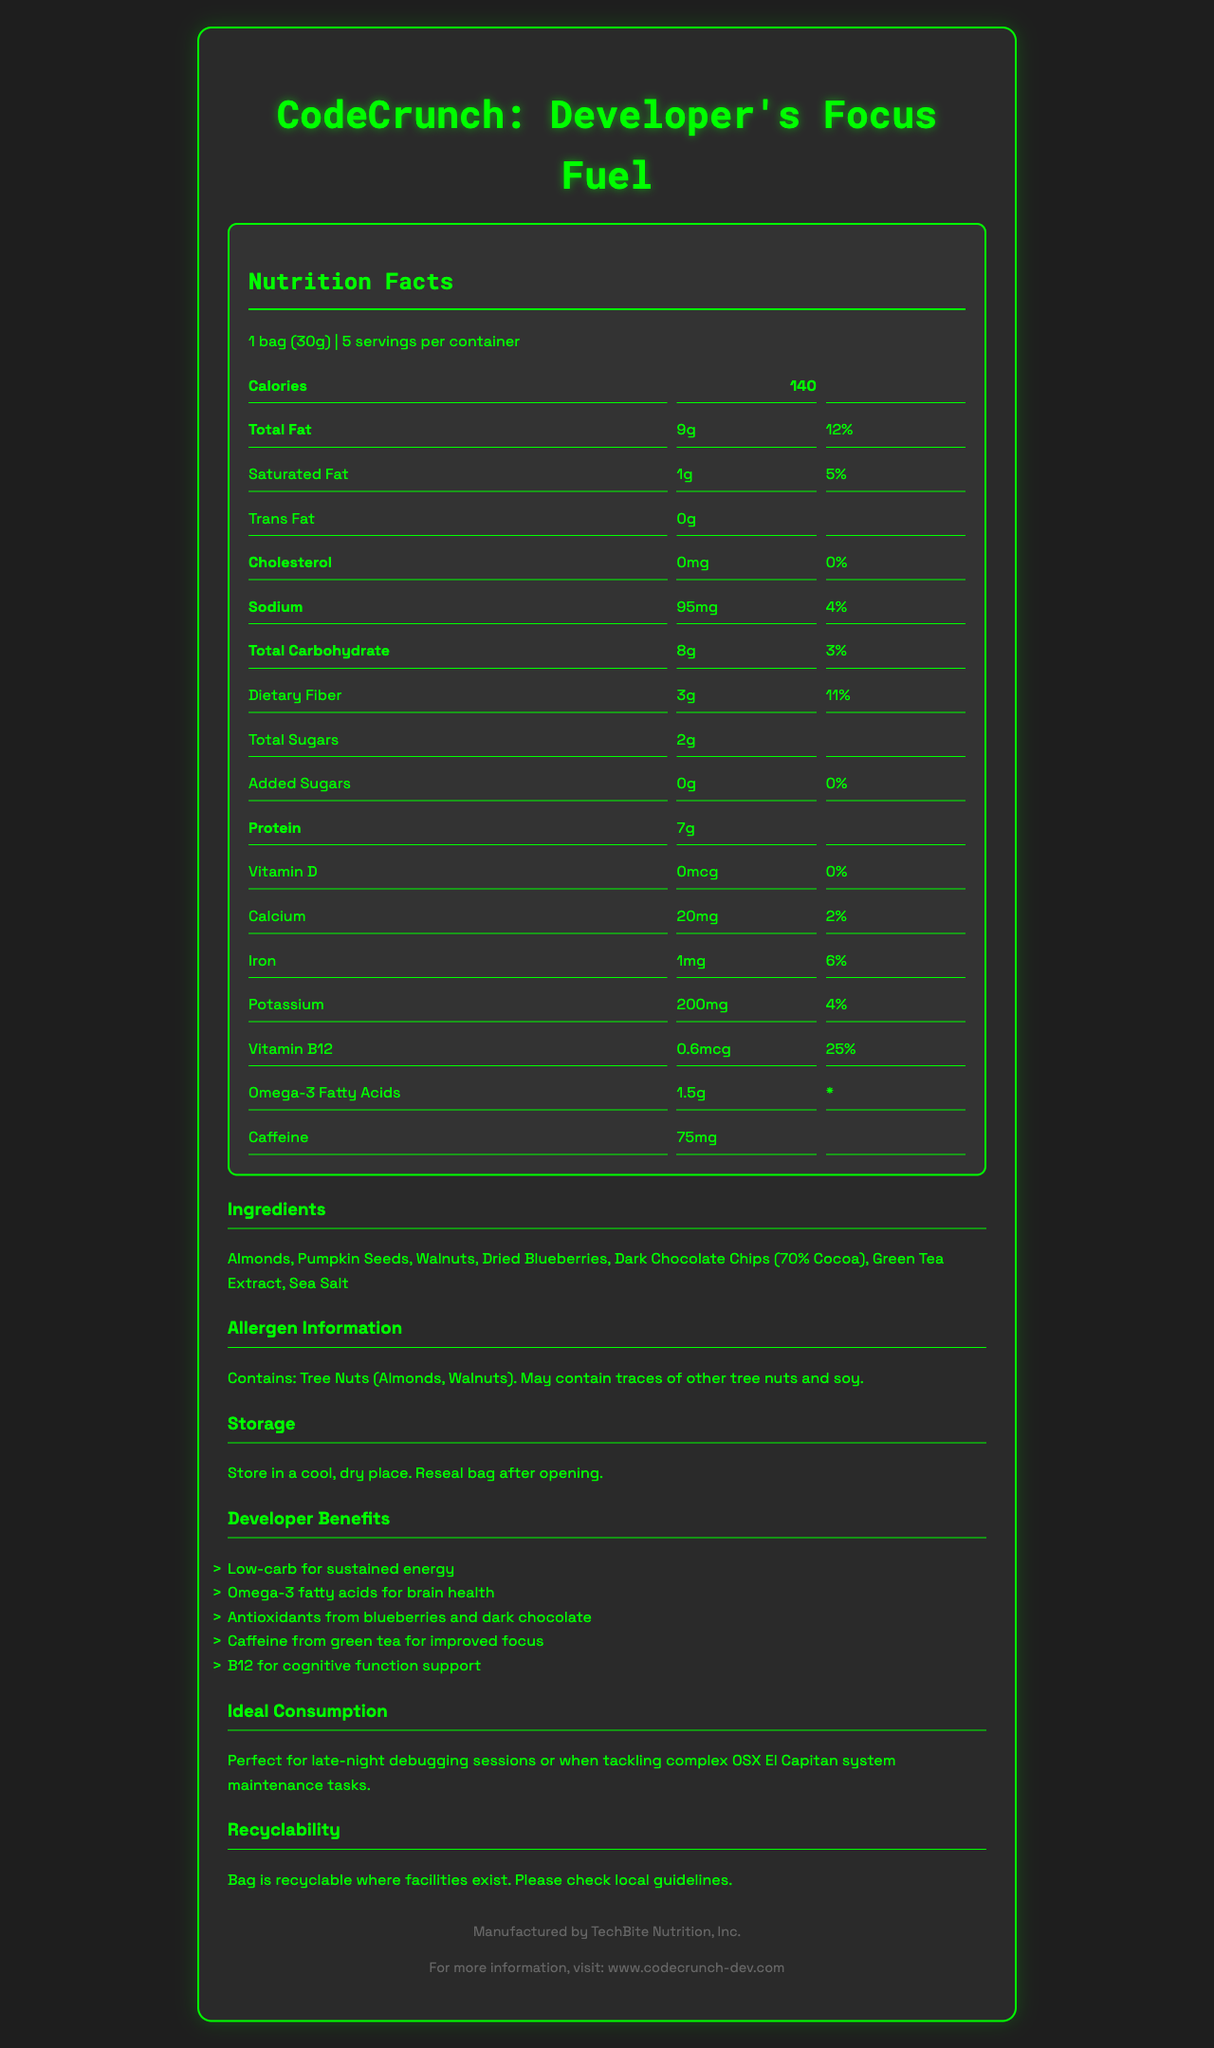what is the serving size of the product? The serving size is provided in the document under the Nutrition Facts header.
Answer: 1 bag (30g) how many servings are there in a container? The document mentions there are 5 servings per container.
Answer: 5 how many calories are in one serving? The calorie count per serving is listed as 140 in the Nutrition Facts section.
Answer: 140 what is the total carbohydrate amount per serving? The total carbohydrate amount per serving is specified as 8g in the nutrition details.
Answer: 8g how much caffeine does each serving contain? The caffeine content per serving is listed as 75mg in the nutrition details.
Answer: 75mg what are the primary ingredients in the snack? The main ingredients are listed under the Ingredients section in the document.
Answer: Almonds, Pumpkin Seeds, Walnuts, Dried Blueberries, Dark Chocolate Chips (70% Cocoa), Green Tea Extract, Sea Salt how much vitamin B12 is in each serving? The document states that each serving contains 0.6mcg of Vitamin B12.
Answer: 0.6mcg Is this product allergen-free? The document specifies that the product contains tree nuts (almonds, walnuts) and may contain traces of other tree nuts and soy.
Answer: No which of the following is NOT an ingredient in the snack? A. Almonds B. Pumpkin Seeds C. Sugar D. Walnuts The listed ingredients include Almonds, Pumpkin Seeds, and Walnuts but do not list Sugar.
Answer: C. Sugar how many grams of dietary fiber are in one serving? A. 1g B. 3g C. 5g D. 8g The dietary fiber content per serving is specified as 3g in the nutrition details.
Answer: B. 3g is the bag recyclable? The document mentions that the bag is recyclable where facilities exist.
Answer: Yes summarize the key features highlighted in the document. The document provides detailed nutritional information, ingredients, allergen info, and benefits of the product, emphasizing its role in boosting focus and brain health for developers, especially during late-night debugging sessions. It also highlights the recyclable nature of the packaging.
Answer: CodeCrunch: Developer's Focus Fuel is a low-carb snack designed to support brain health and focus. It contains 140 calories per serving, 9g of total fat, 7g of protein, and 8g of carbohydrates. Key ingredients include almonds, pumpkin seeds, walnuts, and dried blueberries. The product also offers benefits such as improved focus from caffeine and cognitive support from Vitamin B12. The packaging is recyclable. what is the daily value percentage of calcium in one serving? The daily value percentage of calcium per serving is listed as 2% in the nutrition details.
Answer: 2% which benefit is NOT mentioned for developers? A. Improved focus B. Faster coding speed C. Cognitive support D. Sustained energy The document lists benefits like improved focus, cognitive support, and sustained energy but does not mention anything about faster coding speed.
Answer: B. Faster coding speed where is the product manufactured? The footer of the document indicates that the product is manufactured by TechBite Nutrition, Inc.
Answer: TechBite Nutrition, Inc. how many grams of protein does each serving contain? The document specifies that each serving contains 7g of protein.
Answer: 7g what is the main idea of the document? The document aims to inform consumers about the nutritional content and benefits of CodeCrunch: Developer's Focus Fuel as a brain-boosting snack for developers.
Answer: The Nutrition Facts Label for CodeCrunch: Developer's Focus Fuel provides detailed nutritional information, ingredient list, allergen information, and benefits specifically designed for developers, promoting brain health and focus. does one serving contain any trans fat? The document specifies that each serving contains 0g of trans fat.
Answer: No can you determine the price of the product from the document? The document does not provide any information regarding the price of the product.
Answer: Cannot be determined 